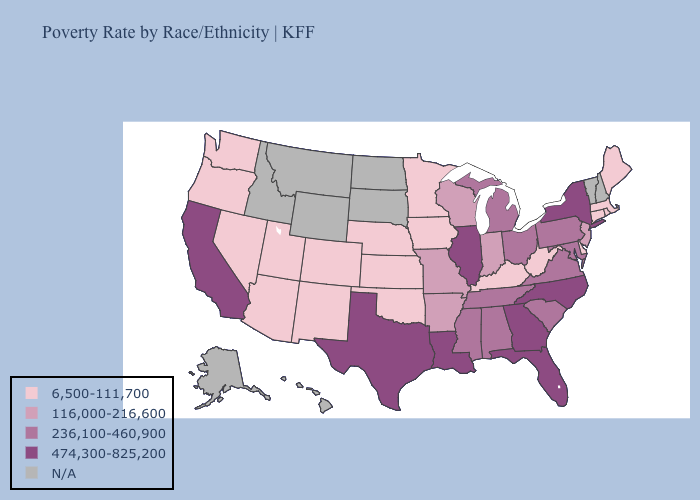Does Georgia have the highest value in the South?
Keep it brief. Yes. Name the states that have a value in the range N/A?
Concise answer only. Alaska, Hawaii, Idaho, Montana, New Hampshire, North Dakota, South Dakota, Vermont, Wyoming. What is the value of Oklahoma?
Answer briefly. 6,500-111,700. What is the lowest value in the South?
Give a very brief answer. 6,500-111,700. Name the states that have a value in the range 474,300-825,200?
Write a very short answer. California, Florida, Georgia, Illinois, Louisiana, New York, North Carolina, Texas. What is the value of Kansas?
Write a very short answer. 6,500-111,700. What is the lowest value in states that border Wisconsin?
Concise answer only. 6,500-111,700. Does the first symbol in the legend represent the smallest category?
Quick response, please. Yes. Does the first symbol in the legend represent the smallest category?
Be succinct. Yes. What is the lowest value in states that border New Hampshire?
Write a very short answer. 6,500-111,700. What is the lowest value in the South?
Concise answer only. 6,500-111,700. Does New York have the lowest value in the USA?
Give a very brief answer. No. Name the states that have a value in the range 474,300-825,200?
Keep it brief. California, Florida, Georgia, Illinois, Louisiana, New York, North Carolina, Texas. Among the states that border Michigan , which have the lowest value?
Keep it brief. Indiana, Wisconsin. 